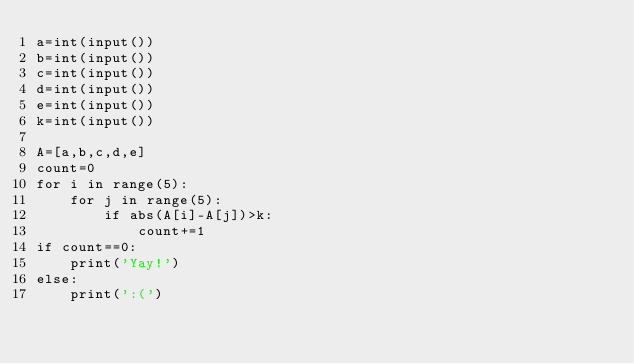<code> <loc_0><loc_0><loc_500><loc_500><_Python_>a=int(input())
b=int(input())
c=int(input())
d=int(input())
e=int(input())
k=int(input())

A=[a,b,c,d,e]
count=0
for i in range(5):
    for j in range(5):
        if abs(A[i]-A[j])>k:
            count+=1
if count==0:
    print('Yay!')
else:
    print(':(')</code> 